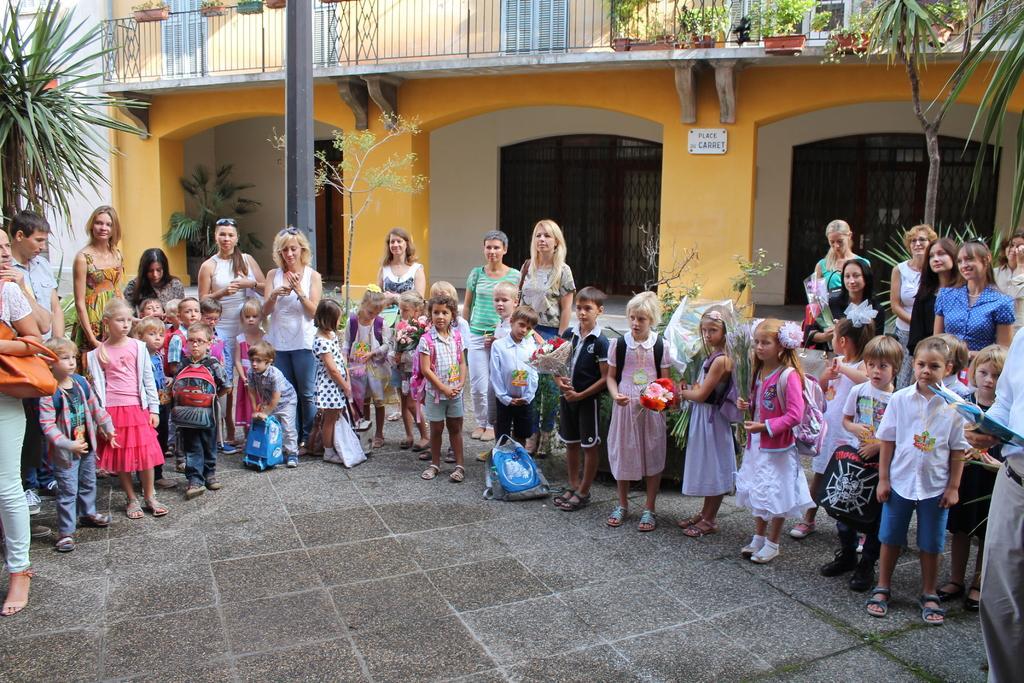Can you describe this image briefly? In this image, we can see people and kids and some of the kids are wearing flowers in their hair and some are wearing bags and holding flower bouquets. In the background, there are trees and we can see flower pots, a board, grilles and a building. At the bottom, there are bags on the floor. 